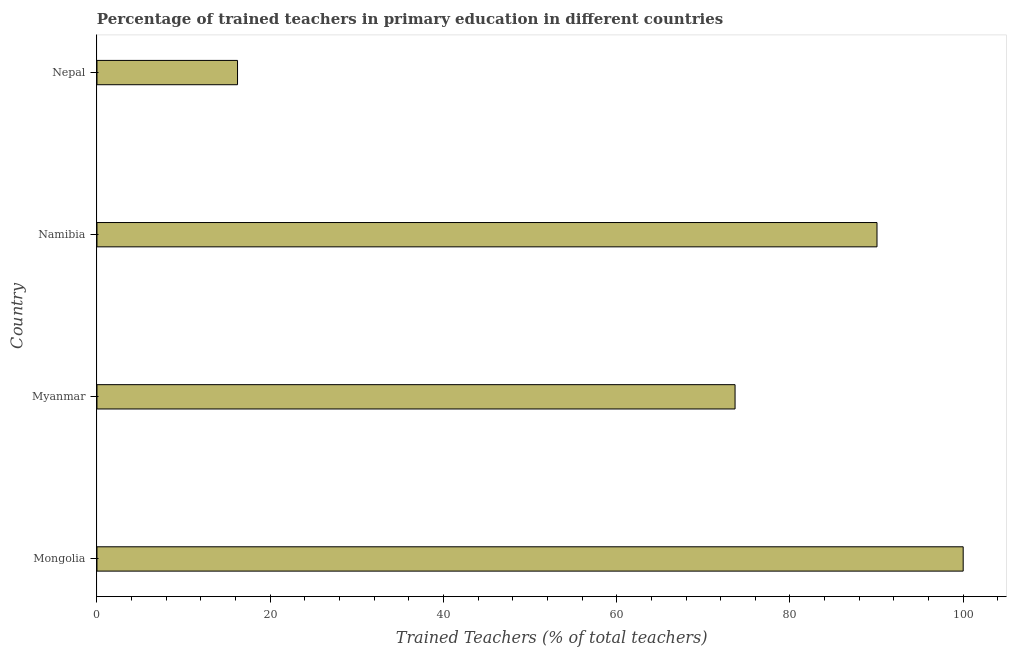Does the graph contain grids?
Your answer should be very brief. No. What is the title of the graph?
Make the answer very short. Percentage of trained teachers in primary education in different countries. What is the label or title of the X-axis?
Your response must be concise. Trained Teachers (% of total teachers). What is the label or title of the Y-axis?
Your response must be concise. Country. What is the percentage of trained teachers in Nepal?
Provide a short and direct response. 16.23. Across all countries, what is the maximum percentage of trained teachers?
Your answer should be compact. 100. Across all countries, what is the minimum percentage of trained teachers?
Your answer should be very brief. 16.23. In which country was the percentage of trained teachers maximum?
Ensure brevity in your answer.  Mongolia. In which country was the percentage of trained teachers minimum?
Your answer should be compact. Nepal. What is the sum of the percentage of trained teachers?
Offer a very short reply. 279.94. What is the difference between the percentage of trained teachers in Mongolia and Namibia?
Provide a short and direct response. 9.95. What is the average percentage of trained teachers per country?
Ensure brevity in your answer.  69.99. What is the median percentage of trained teachers?
Offer a very short reply. 81.86. In how many countries, is the percentage of trained teachers greater than 28 %?
Offer a terse response. 3. What is the ratio of the percentage of trained teachers in Myanmar to that in Namibia?
Make the answer very short. 0.82. What is the difference between the highest and the second highest percentage of trained teachers?
Ensure brevity in your answer.  9.95. Is the sum of the percentage of trained teachers in Mongolia and Myanmar greater than the maximum percentage of trained teachers across all countries?
Make the answer very short. Yes. What is the difference between the highest and the lowest percentage of trained teachers?
Offer a terse response. 83.77. Are all the bars in the graph horizontal?
Provide a short and direct response. Yes. Are the values on the major ticks of X-axis written in scientific E-notation?
Offer a terse response. No. What is the Trained Teachers (% of total teachers) in Mongolia?
Offer a terse response. 100. What is the Trained Teachers (% of total teachers) in Myanmar?
Provide a short and direct response. 73.67. What is the Trained Teachers (% of total teachers) of Namibia?
Provide a succinct answer. 90.05. What is the Trained Teachers (% of total teachers) of Nepal?
Provide a short and direct response. 16.23. What is the difference between the Trained Teachers (% of total teachers) in Mongolia and Myanmar?
Ensure brevity in your answer.  26.33. What is the difference between the Trained Teachers (% of total teachers) in Mongolia and Namibia?
Make the answer very short. 9.95. What is the difference between the Trained Teachers (% of total teachers) in Mongolia and Nepal?
Provide a succinct answer. 83.77. What is the difference between the Trained Teachers (% of total teachers) in Myanmar and Namibia?
Provide a short and direct response. -16.39. What is the difference between the Trained Teachers (% of total teachers) in Myanmar and Nepal?
Offer a very short reply. 57.44. What is the difference between the Trained Teachers (% of total teachers) in Namibia and Nepal?
Provide a succinct answer. 73.82. What is the ratio of the Trained Teachers (% of total teachers) in Mongolia to that in Myanmar?
Make the answer very short. 1.36. What is the ratio of the Trained Teachers (% of total teachers) in Mongolia to that in Namibia?
Provide a short and direct response. 1.11. What is the ratio of the Trained Teachers (% of total teachers) in Mongolia to that in Nepal?
Your response must be concise. 6.16. What is the ratio of the Trained Teachers (% of total teachers) in Myanmar to that in Namibia?
Give a very brief answer. 0.82. What is the ratio of the Trained Teachers (% of total teachers) in Myanmar to that in Nepal?
Give a very brief answer. 4.54. What is the ratio of the Trained Teachers (% of total teachers) in Namibia to that in Nepal?
Offer a very short reply. 5.55. 